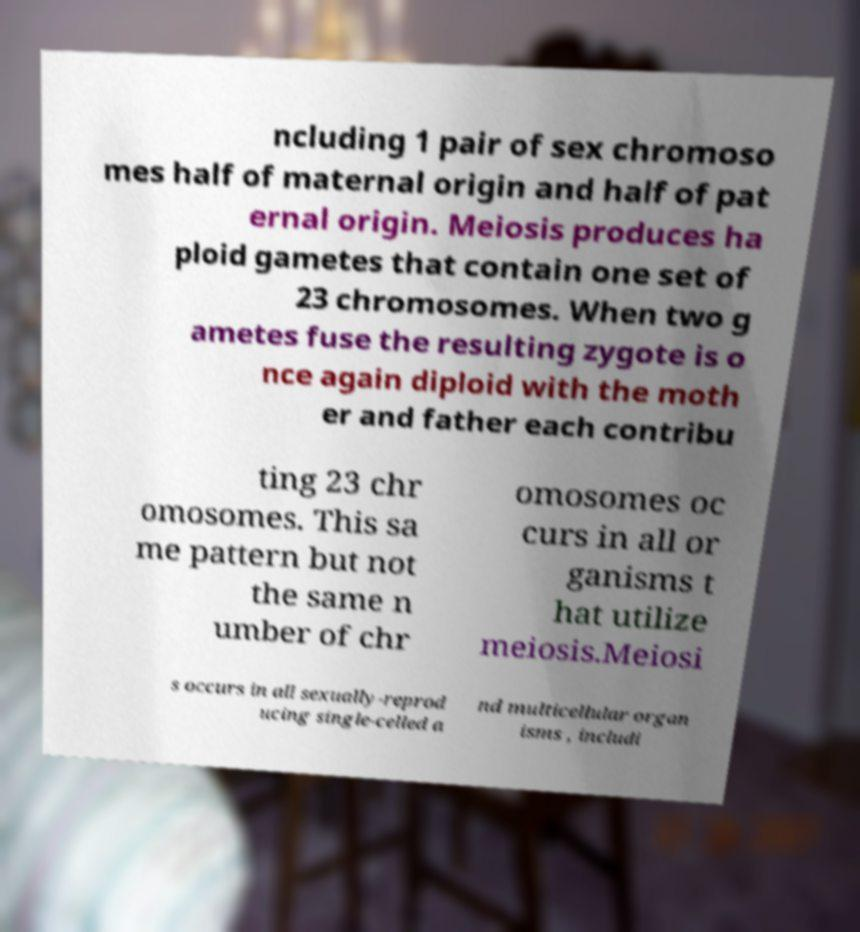Can you read and provide the text displayed in the image?This photo seems to have some interesting text. Can you extract and type it out for me? ncluding 1 pair of sex chromoso mes half of maternal origin and half of pat ernal origin. Meiosis produces ha ploid gametes that contain one set of 23 chromosomes. When two g ametes fuse the resulting zygote is o nce again diploid with the moth er and father each contribu ting 23 chr omosomes. This sa me pattern but not the same n umber of chr omosomes oc curs in all or ganisms t hat utilize meiosis.Meiosi s occurs in all sexually-reprod ucing single-celled a nd multicellular organ isms , includi 